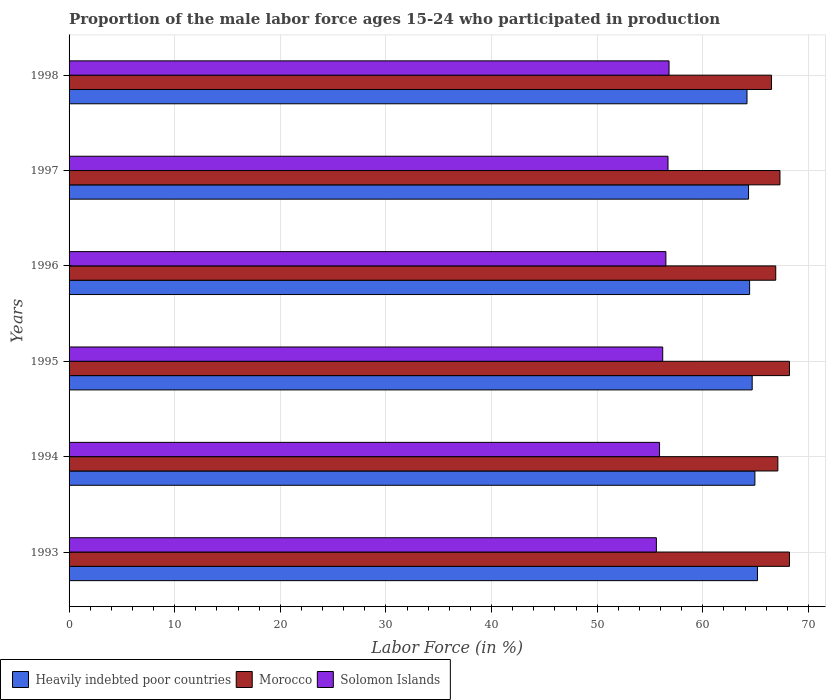How many different coloured bars are there?
Your response must be concise. 3. How many groups of bars are there?
Your response must be concise. 6. What is the label of the 2nd group of bars from the top?
Offer a terse response. 1997. In how many cases, is the number of bars for a given year not equal to the number of legend labels?
Make the answer very short. 0. What is the proportion of the male labor force who participated in production in Morocco in 1997?
Your response must be concise. 67.3. Across all years, what is the maximum proportion of the male labor force who participated in production in Morocco?
Your response must be concise. 68.2. Across all years, what is the minimum proportion of the male labor force who participated in production in Heavily indebted poor countries?
Give a very brief answer. 64.18. What is the total proportion of the male labor force who participated in production in Solomon Islands in the graph?
Provide a short and direct response. 337.7. What is the difference between the proportion of the male labor force who participated in production in Heavily indebted poor countries in 1995 and that in 1996?
Your answer should be compact. 0.24. What is the difference between the proportion of the male labor force who participated in production in Morocco in 1993 and the proportion of the male labor force who participated in production in Heavily indebted poor countries in 1998?
Offer a terse response. 4.02. What is the average proportion of the male labor force who participated in production in Solomon Islands per year?
Ensure brevity in your answer.  56.28. In the year 1994, what is the difference between the proportion of the male labor force who participated in production in Heavily indebted poor countries and proportion of the male labor force who participated in production in Solomon Islands?
Offer a terse response. 9.03. What is the ratio of the proportion of the male labor force who participated in production in Solomon Islands in 1994 to that in 1998?
Offer a terse response. 0.98. What is the difference between the highest and the second highest proportion of the male labor force who participated in production in Solomon Islands?
Offer a terse response. 0.1. What is the difference between the highest and the lowest proportion of the male labor force who participated in production in Solomon Islands?
Provide a succinct answer. 1.2. In how many years, is the proportion of the male labor force who participated in production in Solomon Islands greater than the average proportion of the male labor force who participated in production in Solomon Islands taken over all years?
Offer a very short reply. 3. What does the 1st bar from the top in 1997 represents?
Make the answer very short. Solomon Islands. What does the 3rd bar from the bottom in 1996 represents?
Provide a short and direct response. Solomon Islands. Is it the case that in every year, the sum of the proportion of the male labor force who participated in production in Morocco and proportion of the male labor force who participated in production in Heavily indebted poor countries is greater than the proportion of the male labor force who participated in production in Solomon Islands?
Provide a short and direct response. Yes. How many bars are there?
Your response must be concise. 18. How many years are there in the graph?
Provide a short and direct response. 6. What is the difference between two consecutive major ticks on the X-axis?
Your answer should be very brief. 10. Are the values on the major ticks of X-axis written in scientific E-notation?
Make the answer very short. No. Does the graph contain any zero values?
Provide a short and direct response. No. How are the legend labels stacked?
Give a very brief answer. Horizontal. What is the title of the graph?
Make the answer very short. Proportion of the male labor force ages 15-24 who participated in production. Does "Jamaica" appear as one of the legend labels in the graph?
Offer a very short reply. No. What is the label or title of the Y-axis?
Ensure brevity in your answer.  Years. What is the Labor Force (in %) of Heavily indebted poor countries in 1993?
Offer a terse response. 65.17. What is the Labor Force (in %) of Morocco in 1993?
Ensure brevity in your answer.  68.2. What is the Labor Force (in %) of Solomon Islands in 1993?
Give a very brief answer. 55.6. What is the Labor Force (in %) in Heavily indebted poor countries in 1994?
Make the answer very short. 64.93. What is the Labor Force (in %) in Morocco in 1994?
Provide a short and direct response. 67.1. What is the Labor Force (in %) in Solomon Islands in 1994?
Provide a succinct answer. 55.9. What is the Labor Force (in %) in Heavily indebted poor countries in 1995?
Keep it short and to the point. 64.67. What is the Labor Force (in %) in Morocco in 1995?
Make the answer very short. 68.2. What is the Labor Force (in %) in Solomon Islands in 1995?
Offer a terse response. 56.2. What is the Labor Force (in %) in Heavily indebted poor countries in 1996?
Provide a succinct answer. 64.43. What is the Labor Force (in %) in Morocco in 1996?
Give a very brief answer. 66.9. What is the Labor Force (in %) in Solomon Islands in 1996?
Your answer should be very brief. 56.5. What is the Labor Force (in %) of Heavily indebted poor countries in 1997?
Keep it short and to the point. 64.33. What is the Labor Force (in %) of Morocco in 1997?
Provide a succinct answer. 67.3. What is the Labor Force (in %) in Solomon Islands in 1997?
Your answer should be compact. 56.7. What is the Labor Force (in %) in Heavily indebted poor countries in 1998?
Make the answer very short. 64.18. What is the Labor Force (in %) of Morocco in 1998?
Provide a succinct answer. 66.5. What is the Labor Force (in %) of Solomon Islands in 1998?
Keep it short and to the point. 56.8. Across all years, what is the maximum Labor Force (in %) in Heavily indebted poor countries?
Provide a short and direct response. 65.17. Across all years, what is the maximum Labor Force (in %) in Morocco?
Your response must be concise. 68.2. Across all years, what is the maximum Labor Force (in %) in Solomon Islands?
Offer a very short reply. 56.8. Across all years, what is the minimum Labor Force (in %) in Heavily indebted poor countries?
Offer a terse response. 64.18. Across all years, what is the minimum Labor Force (in %) of Morocco?
Provide a short and direct response. 66.5. Across all years, what is the minimum Labor Force (in %) of Solomon Islands?
Offer a very short reply. 55.6. What is the total Labor Force (in %) of Heavily indebted poor countries in the graph?
Keep it short and to the point. 387.7. What is the total Labor Force (in %) of Morocco in the graph?
Make the answer very short. 404.2. What is the total Labor Force (in %) in Solomon Islands in the graph?
Your answer should be compact. 337.7. What is the difference between the Labor Force (in %) in Heavily indebted poor countries in 1993 and that in 1994?
Offer a very short reply. 0.25. What is the difference between the Labor Force (in %) in Morocco in 1993 and that in 1994?
Ensure brevity in your answer.  1.1. What is the difference between the Labor Force (in %) of Heavily indebted poor countries in 1993 and that in 1995?
Offer a very short reply. 0.5. What is the difference between the Labor Force (in %) of Morocco in 1993 and that in 1995?
Provide a short and direct response. 0. What is the difference between the Labor Force (in %) in Heavily indebted poor countries in 1993 and that in 1996?
Ensure brevity in your answer.  0.74. What is the difference between the Labor Force (in %) of Morocco in 1993 and that in 1996?
Your response must be concise. 1.3. What is the difference between the Labor Force (in %) in Heavily indebted poor countries in 1993 and that in 1997?
Your response must be concise. 0.85. What is the difference between the Labor Force (in %) of Heavily indebted poor countries in 1993 and that in 1998?
Your answer should be compact. 0.99. What is the difference between the Labor Force (in %) in Morocco in 1993 and that in 1998?
Keep it short and to the point. 1.7. What is the difference between the Labor Force (in %) in Heavily indebted poor countries in 1994 and that in 1995?
Provide a short and direct response. 0.26. What is the difference between the Labor Force (in %) of Morocco in 1994 and that in 1995?
Ensure brevity in your answer.  -1.1. What is the difference between the Labor Force (in %) in Heavily indebted poor countries in 1994 and that in 1996?
Your response must be concise. 0.5. What is the difference between the Labor Force (in %) of Solomon Islands in 1994 and that in 1996?
Make the answer very short. -0.6. What is the difference between the Labor Force (in %) in Heavily indebted poor countries in 1994 and that in 1997?
Offer a very short reply. 0.6. What is the difference between the Labor Force (in %) of Morocco in 1994 and that in 1997?
Offer a terse response. -0.2. What is the difference between the Labor Force (in %) of Heavily indebted poor countries in 1994 and that in 1998?
Ensure brevity in your answer.  0.75. What is the difference between the Labor Force (in %) in Solomon Islands in 1994 and that in 1998?
Offer a terse response. -0.9. What is the difference between the Labor Force (in %) in Heavily indebted poor countries in 1995 and that in 1996?
Offer a terse response. 0.24. What is the difference between the Labor Force (in %) of Solomon Islands in 1995 and that in 1996?
Give a very brief answer. -0.3. What is the difference between the Labor Force (in %) in Heavily indebted poor countries in 1995 and that in 1997?
Provide a short and direct response. 0.35. What is the difference between the Labor Force (in %) of Solomon Islands in 1995 and that in 1997?
Provide a succinct answer. -0.5. What is the difference between the Labor Force (in %) in Heavily indebted poor countries in 1995 and that in 1998?
Provide a short and direct response. 0.49. What is the difference between the Labor Force (in %) in Morocco in 1995 and that in 1998?
Your answer should be compact. 1.7. What is the difference between the Labor Force (in %) in Solomon Islands in 1995 and that in 1998?
Your answer should be very brief. -0.6. What is the difference between the Labor Force (in %) of Heavily indebted poor countries in 1996 and that in 1997?
Provide a succinct answer. 0.1. What is the difference between the Labor Force (in %) of Heavily indebted poor countries in 1996 and that in 1998?
Offer a terse response. 0.25. What is the difference between the Labor Force (in %) of Heavily indebted poor countries in 1997 and that in 1998?
Provide a succinct answer. 0.15. What is the difference between the Labor Force (in %) of Heavily indebted poor countries in 1993 and the Labor Force (in %) of Morocco in 1994?
Offer a terse response. -1.93. What is the difference between the Labor Force (in %) of Heavily indebted poor countries in 1993 and the Labor Force (in %) of Solomon Islands in 1994?
Ensure brevity in your answer.  9.27. What is the difference between the Labor Force (in %) of Morocco in 1993 and the Labor Force (in %) of Solomon Islands in 1994?
Provide a succinct answer. 12.3. What is the difference between the Labor Force (in %) of Heavily indebted poor countries in 1993 and the Labor Force (in %) of Morocco in 1995?
Your response must be concise. -3.03. What is the difference between the Labor Force (in %) in Heavily indebted poor countries in 1993 and the Labor Force (in %) in Solomon Islands in 1995?
Make the answer very short. 8.97. What is the difference between the Labor Force (in %) in Heavily indebted poor countries in 1993 and the Labor Force (in %) in Morocco in 1996?
Provide a short and direct response. -1.73. What is the difference between the Labor Force (in %) of Heavily indebted poor countries in 1993 and the Labor Force (in %) of Solomon Islands in 1996?
Provide a succinct answer. 8.67. What is the difference between the Labor Force (in %) of Morocco in 1993 and the Labor Force (in %) of Solomon Islands in 1996?
Provide a short and direct response. 11.7. What is the difference between the Labor Force (in %) of Heavily indebted poor countries in 1993 and the Labor Force (in %) of Morocco in 1997?
Your response must be concise. -2.13. What is the difference between the Labor Force (in %) in Heavily indebted poor countries in 1993 and the Labor Force (in %) in Solomon Islands in 1997?
Offer a very short reply. 8.47. What is the difference between the Labor Force (in %) of Morocco in 1993 and the Labor Force (in %) of Solomon Islands in 1997?
Provide a succinct answer. 11.5. What is the difference between the Labor Force (in %) of Heavily indebted poor countries in 1993 and the Labor Force (in %) of Morocco in 1998?
Your answer should be very brief. -1.33. What is the difference between the Labor Force (in %) of Heavily indebted poor countries in 1993 and the Labor Force (in %) of Solomon Islands in 1998?
Your answer should be very brief. 8.37. What is the difference between the Labor Force (in %) of Heavily indebted poor countries in 1994 and the Labor Force (in %) of Morocco in 1995?
Provide a short and direct response. -3.27. What is the difference between the Labor Force (in %) in Heavily indebted poor countries in 1994 and the Labor Force (in %) in Solomon Islands in 1995?
Your answer should be compact. 8.73. What is the difference between the Labor Force (in %) in Morocco in 1994 and the Labor Force (in %) in Solomon Islands in 1995?
Your response must be concise. 10.9. What is the difference between the Labor Force (in %) in Heavily indebted poor countries in 1994 and the Labor Force (in %) in Morocco in 1996?
Offer a very short reply. -1.97. What is the difference between the Labor Force (in %) in Heavily indebted poor countries in 1994 and the Labor Force (in %) in Solomon Islands in 1996?
Make the answer very short. 8.43. What is the difference between the Labor Force (in %) of Morocco in 1994 and the Labor Force (in %) of Solomon Islands in 1996?
Ensure brevity in your answer.  10.6. What is the difference between the Labor Force (in %) of Heavily indebted poor countries in 1994 and the Labor Force (in %) of Morocco in 1997?
Your answer should be very brief. -2.37. What is the difference between the Labor Force (in %) of Heavily indebted poor countries in 1994 and the Labor Force (in %) of Solomon Islands in 1997?
Your answer should be compact. 8.23. What is the difference between the Labor Force (in %) in Heavily indebted poor countries in 1994 and the Labor Force (in %) in Morocco in 1998?
Keep it short and to the point. -1.57. What is the difference between the Labor Force (in %) of Heavily indebted poor countries in 1994 and the Labor Force (in %) of Solomon Islands in 1998?
Provide a short and direct response. 8.13. What is the difference between the Labor Force (in %) of Heavily indebted poor countries in 1995 and the Labor Force (in %) of Morocco in 1996?
Provide a succinct answer. -2.23. What is the difference between the Labor Force (in %) of Heavily indebted poor countries in 1995 and the Labor Force (in %) of Solomon Islands in 1996?
Offer a terse response. 8.17. What is the difference between the Labor Force (in %) of Heavily indebted poor countries in 1995 and the Labor Force (in %) of Morocco in 1997?
Provide a succinct answer. -2.63. What is the difference between the Labor Force (in %) of Heavily indebted poor countries in 1995 and the Labor Force (in %) of Solomon Islands in 1997?
Make the answer very short. 7.97. What is the difference between the Labor Force (in %) in Morocco in 1995 and the Labor Force (in %) in Solomon Islands in 1997?
Offer a very short reply. 11.5. What is the difference between the Labor Force (in %) of Heavily indebted poor countries in 1995 and the Labor Force (in %) of Morocco in 1998?
Offer a very short reply. -1.83. What is the difference between the Labor Force (in %) in Heavily indebted poor countries in 1995 and the Labor Force (in %) in Solomon Islands in 1998?
Your answer should be very brief. 7.87. What is the difference between the Labor Force (in %) in Heavily indebted poor countries in 1996 and the Labor Force (in %) in Morocco in 1997?
Ensure brevity in your answer.  -2.87. What is the difference between the Labor Force (in %) of Heavily indebted poor countries in 1996 and the Labor Force (in %) of Solomon Islands in 1997?
Provide a short and direct response. 7.73. What is the difference between the Labor Force (in %) of Heavily indebted poor countries in 1996 and the Labor Force (in %) of Morocco in 1998?
Keep it short and to the point. -2.07. What is the difference between the Labor Force (in %) of Heavily indebted poor countries in 1996 and the Labor Force (in %) of Solomon Islands in 1998?
Offer a very short reply. 7.63. What is the difference between the Labor Force (in %) in Morocco in 1996 and the Labor Force (in %) in Solomon Islands in 1998?
Ensure brevity in your answer.  10.1. What is the difference between the Labor Force (in %) in Heavily indebted poor countries in 1997 and the Labor Force (in %) in Morocco in 1998?
Your answer should be very brief. -2.17. What is the difference between the Labor Force (in %) in Heavily indebted poor countries in 1997 and the Labor Force (in %) in Solomon Islands in 1998?
Give a very brief answer. 7.53. What is the average Labor Force (in %) of Heavily indebted poor countries per year?
Your answer should be compact. 64.62. What is the average Labor Force (in %) of Morocco per year?
Your response must be concise. 67.37. What is the average Labor Force (in %) of Solomon Islands per year?
Ensure brevity in your answer.  56.28. In the year 1993, what is the difference between the Labor Force (in %) of Heavily indebted poor countries and Labor Force (in %) of Morocco?
Provide a short and direct response. -3.03. In the year 1993, what is the difference between the Labor Force (in %) in Heavily indebted poor countries and Labor Force (in %) in Solomon Islands?
Your response must be concise. 9.57. In the year 1994, what is the difference between the Labor Force (in %) in Heavily indebted poor countries and Labor Force (in %) in Morocco?
Give a very brief answer. -2.17. In the year 1994, what is the difference between the Labor Force (in %) of Heavily indebted poor countries and Labor Force (in %) of Solomon Islands?
Keep it short and to the point. 9.03. In the year 1994, what is the difference between the Labor Force (in %) in Morocco and Labor Force (in %) in Solomon Islands?
Ensure brevity in your answer.  11.2. In the year 1995, what is the difference between the Labor Force (in %) of Heavily indebted poor countries and Labor Force (in %) of Morocco?
Provide a succinct answer. -3.53. In the year 1995, what is the difference between the Labor Force (in %) in Heavily indebted poor countries and Labor Force (in %) in Solomon Islands?
Your answer should be compact. 8.47. In the year 1995, what is the difference between the Labor Force (in %) in Morocco and Labor Force (in %) in Solomon Islands?
Your response must be concise. 12. In the year 1996, what is the difference between the Labor Force (in %) of Heavily indebted poor countries and Labor Force (in %) of Morocco?
Provide a short and direct response. -2.47. In the year 1996, what is the difference between the Labor Force (in %) of Heavily indebted poor countries and Labor Force (in %) of Solomon Islands?
Your response must be concise. 7.93. In the year 1997, what is the difference between the Labor Force (in %) in Heavily indebted poor countries and Labor Force (in %) in Morocco?
Provide a short and direct response. -2.97. In the year 1997, what is the difference between the Labor Force (in %) in Heavily indebted poor countries and Labor Force (in %) in Solomon Islands?
Keep it short and to the point. 7.63. In the year 1997, what is the difference between the Labor Force (in %) in Morocco and Labor Force (in %) in Solomon Islands?
Offer a terse response. 10.6. In the year 1998, what is the difference between the Labor Force (in %) of Heavily indebted poor countries and Labor Force (in %) of Morocco?
Provide a short and direct response. -2.32. In the year 1998, what is the difference between the Labor Force (in %) of Heavily indebted poor countries and Labor Force (in %) of Solomon Islands?
Keep it short and to the point. 7.38. What is the ratio of the Labor Force (in %) of Heavily indebted poor countries in 1993 to that in 1994?
Offer a very short reply. 1. What is the ratio of the Labor Force (in %) in Morocco in 1993 to that in 1994?
Ensure brevity in your answer.  1.02. What is the ratio of the Labor Force (in %) of Solomon Islands in 1993 to that in 1994?
Make the answer very short. 0.99. What is the ratio of the Labor Force (in %) in Heavily indebted poor countries in 1993 to that in 1995?
Offer a terse response. 1.01. What is the ratio of the Labor Force (in %) of Solomon Islands in 1993 to that in 1995?
Keep it short and to the point. 0.99. What is the ratio of the Labor Force (in %) of Heavily indebted poor countries in 1993 to that in 1996?
Offer a very short reply. 1.01. What is the ratio of the Labor Force (in %) in Morocco in 1993 to that in 1996?
Keep it short and to the point. 1.02. What is the ratio of the Labor Force (in %) of Solomon Islands in 1993 to that in 1996?
Keep it short and to the point. 0.98. What is the ratio of the Labor Force (in %) of Heavily indebted poor countries in 1993 to that in 1997?
Offer a terse response. 1.01. What is the ratio of the Labor Force (in %) of Morocco in 1993 to that in 1997?
Your answer should be compact. 1.01. What is the ratio of the Labor Force (in %) of Solomon Islands in 1993 to that in 1997?
Keep it short and to the point. 0.98. What is the ratio of the Labor Force (in %) of Heavily indebted poor countries in 1993 to that in 1998?
Make the answer very short. 1.02. What is the ratio of the Labor Force (in %) of Morocco in 1993 to that in 1998?
Ensure brevity in your answer.  1.03. What is the ratio of the Labor Force (in %) of Solomon Islands in 1993 to that in 1998?
Offer a very short reply. 0.98. What is the ratio of the Labor Force (in %) of Heavily indebted poor countries in 1994 to that in 1995?
Your answer should be very brief. 1. What is the ratio of the Labor Force (in %) of Morocco in 1994 to that in 1995?
Keep it short and to the point. 0.98. What is the ratio of the Labor Force (in %) in Solomon Islands in 1994 to that in 1995?
Offer a terse response. 0.99. What is the ratio of the Labor Force (in %) in Heavily indebted poor countries in 1994 to that in 1996?
Provide a succinct answer. 1.01. What is the ratio of the Labor Force (in %) of Solomon Islands in 1994 to that in 1996?
Your answer should be compact. 0.99. What is the ratio of the Labor Force (in %) of Heavily indebted poor countries in 1994 to that in 1997?
Ensure brevity in your answer.  1.01. What is the ratio of the Labor Force (in %) in Solomon Islands in 1994 to that in 1997?
Offer a very short reply. 0.99. What is the ratio of the Labor Force (in %) in Heavily indebted poor countries in 1994 to that in 1998?
Provide a short and direct response. 1.01. What is the ratio of the Labor Force (in %) of Morocco in 1994 to that in 1998?
Offer a very short reply. 1.01. What is the ratio of the Labor Force (in %) of Solomon Islands in 1994 to that in 1998?
Offer a very short reply. 0.98. What is the ratio of the Labor Force (in %) in Heavily indebted poor countries in 1995 to that in 1996?
Your answer should be very brief. 1. What is the ratio of the Labor Force (in %) of Morocco in 1995 to that in 1996?
Your answer should be compact. 1.02. What is the ratio of the Labor Force (in %) in Heavily indebted poor countries in 1995 to that in 1997?
Your response must be concise. 1.01. What is the ratio of the Labor Force (in %) in Morocco in 1995 to that in 1997?
Provide a succinct answer. 1.01. What is the ratio of the Labor Force (in %) of Solomon Islands in 1995 to that in 1997?
Make the answer very short. 0.99. What is the ratio of the Labor Force (in %) of Heavily indebted poor countries in 1995 to that in 1998?
Your answer should be compact. 1.01. What is the ratio of the Labor Force (in %) of Morocco in 1995 to that in 1998?
Your response must be concise. 1.03. What is the ratio of the Labor Force (in %) of Heavily indebted poor countries in 1996 to that in 1997?
Ensure brevity in your answer.  1. What is the ratio of the Labor Force (in %) of Morocco in 1996 to that in 1997?
Your answer should be very brief. 0.99. What is the ratio of the Labor Force (in %) of Solomon Islands in 1996 to that in 1997?
Give a very brief answer. 1. What is the ratio of the Labor Force (in %) of Heavily indebted poor countries in 1996 to that in 1998?
Your answer should be compact. 1. What is the ratio of the Labor Force (in %) in Morocco in 1996 to that in 1998?
Your answer should be very brief. 1.01. What is the ratio of the Labor Force (in %) of Solomon Islands in 1996 to that in 1998?
Your response must be concise. 0.99. What is the ratio of the Labor Force (in %) of Heavily indebted poor countries in 1997 to that in 1998?
Offer a terse response. 1. What is the ratio of the Labor Force (in %) of Morocco in 1997 to that in 1998?
Ensure brevity in your answer.  1.01. What is the ratio of the Labor Force (in %) of Solomon Islands in 1997 to that in 1998?
Keep it short and to the point. 1. What is the difference between the highest and the second highest Labor Force (in %) of Heavily indebted poor countries?
Your answer should be compact. 0.25. What is the difference between the highest and the second highest Labor Force (in %) in Morocco?
Your answer should be compact. 0. What is the difference between the highest and the second highest Labor Force (in %) in Solomon Islands?
Provide a succinct answer. 0.1. What is the difference between the highest and the lowest Labor Force (in %) in Heavily indebted poor countries?
Provide a succinct answer. 0.99. What is the difference between the highest and the lowest Labor Force (in %) of Morocco?
Your answer should be compact. 1.7. What is the difference between the highest and the lowest Labor Force (in %) in Solomon Islands?
Your answer should be very brief. 1.2. 